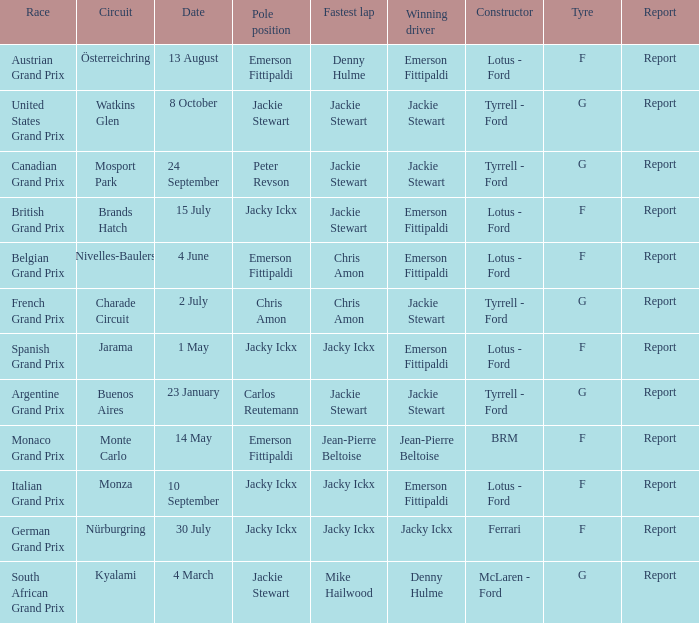What circuit was the British Grand Prix? Brands Hatch. 